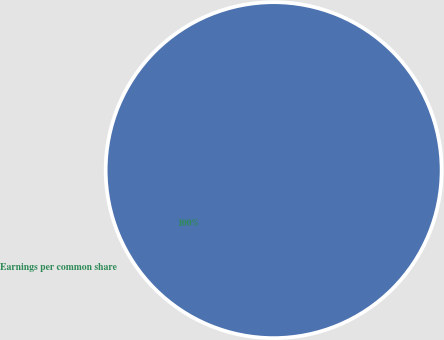<chart> <loc_0><loc_0><loc_500><loc_500><pie_chart><fcel>Earnings per common share<nl><fcel>100.0%<nl></chart> 